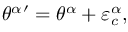<formula> <loc_0><loc_0><loc_500><loc_500>{ \theta ^ { \alpha } ^ { \prime } = { \theta ^ { \alpha } } + \varepsilon _ { c } ^ { \alpha } ,</formula> 